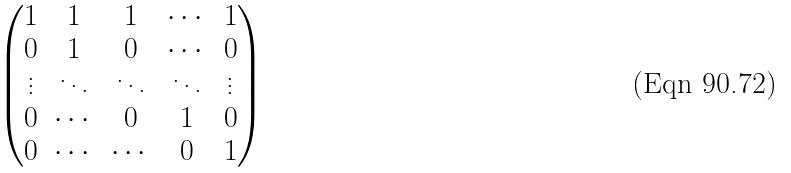<formula> <loc_0><loc_0><loc_500><loc_500>\begin{pmatrix} 1 & 1 & 1 & \cdots & 1 \\ 0 & 1 & 0 & \cdots & 0 \\ \vdots & \ddots & \ddots & \ddots & \vdots \\ 0 & \cdots & 0 & 1 & 0 \\ 0 & \cdots & \cdots & 0 & 1 \end{pmatrix}</formula> 